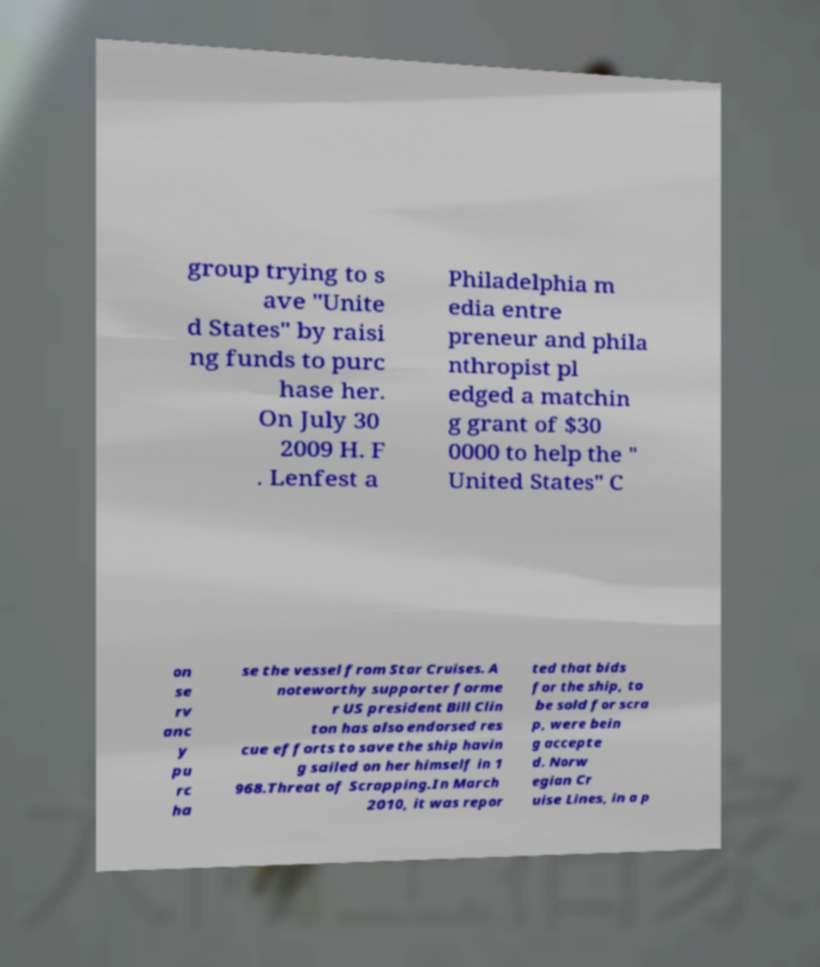Could you extract and type out the text from this image? group trying to s ave "Unite d States" by raisi ng funds to purc hase her. On July 30 2009 H. F . Lenfest a Philadelphia m edia entre preneur and phila nthropist pl edged a matchin g grant of $30 0000 to help the " United States" C on se rv anc y pu rc ha se the vessel from Star Cruises. A noteworthy supporter forme r US president Bill Clin ton has also endorsed res cue efforts to save the ship havin g sailed on her himself in 1 968.Threat of Scrapping.In March 2010, it was repor ted that bids for the ship, to be sold for scra p, were bein g accepte d. Norw egian Cr uise Lines, in a p 